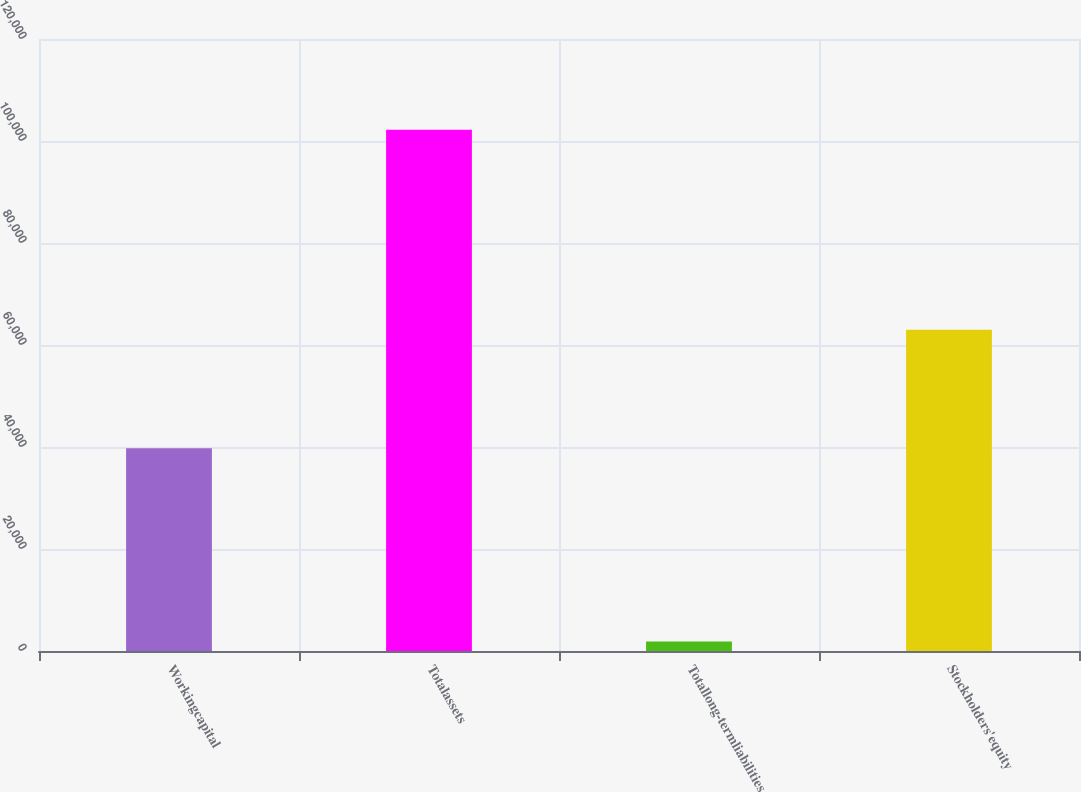Convert chart. <chart><loc_0><loc_0><loc_500><loc_500><bar_chart><fcel>Workingcapital<fcel>Totalassets<fcel>Totallong-termliabilities<fcel>Stockholders'equity<nl><fcel>39737<fcel>102202<fcel>1849<fcel>62976<nl></chart> 